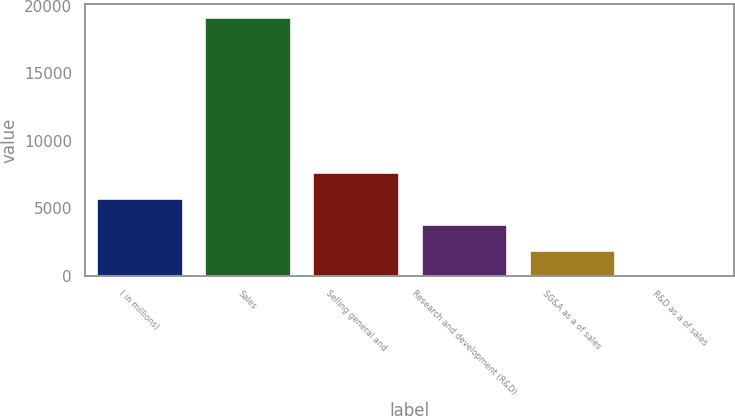<chart> <loc_0><loc_0><loc_500><loc_500><bar_chart><fcel>( in millions)<fcel>Sales<fcel>Selling general and<fcel>Research and development (R&D)<fcel>SG&A as a of sales<fcel>R&D as a of sales<nl><fcel>5750.4<fcel>19154<fcel>7665.2<fcel>3835.6<fcel>1920.8<fcel>6<nl></chart> 